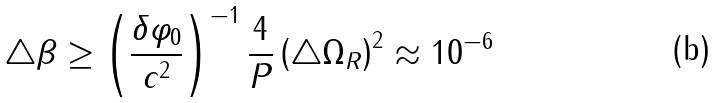Convert formula to latex. <formula><loc_0><loc_0><loc_500><loc_500>\triangle \beta \geq \left ( \frac { \delta \varphi _ { 0 } } { c ^ { 2 } } \right ) ^ { - 1 } \frac { 4 } P \left ( \triangle \Omega _ { R } \right ) ^ { 2 } \approx 1 0 ^ { - 6 }</formula> 